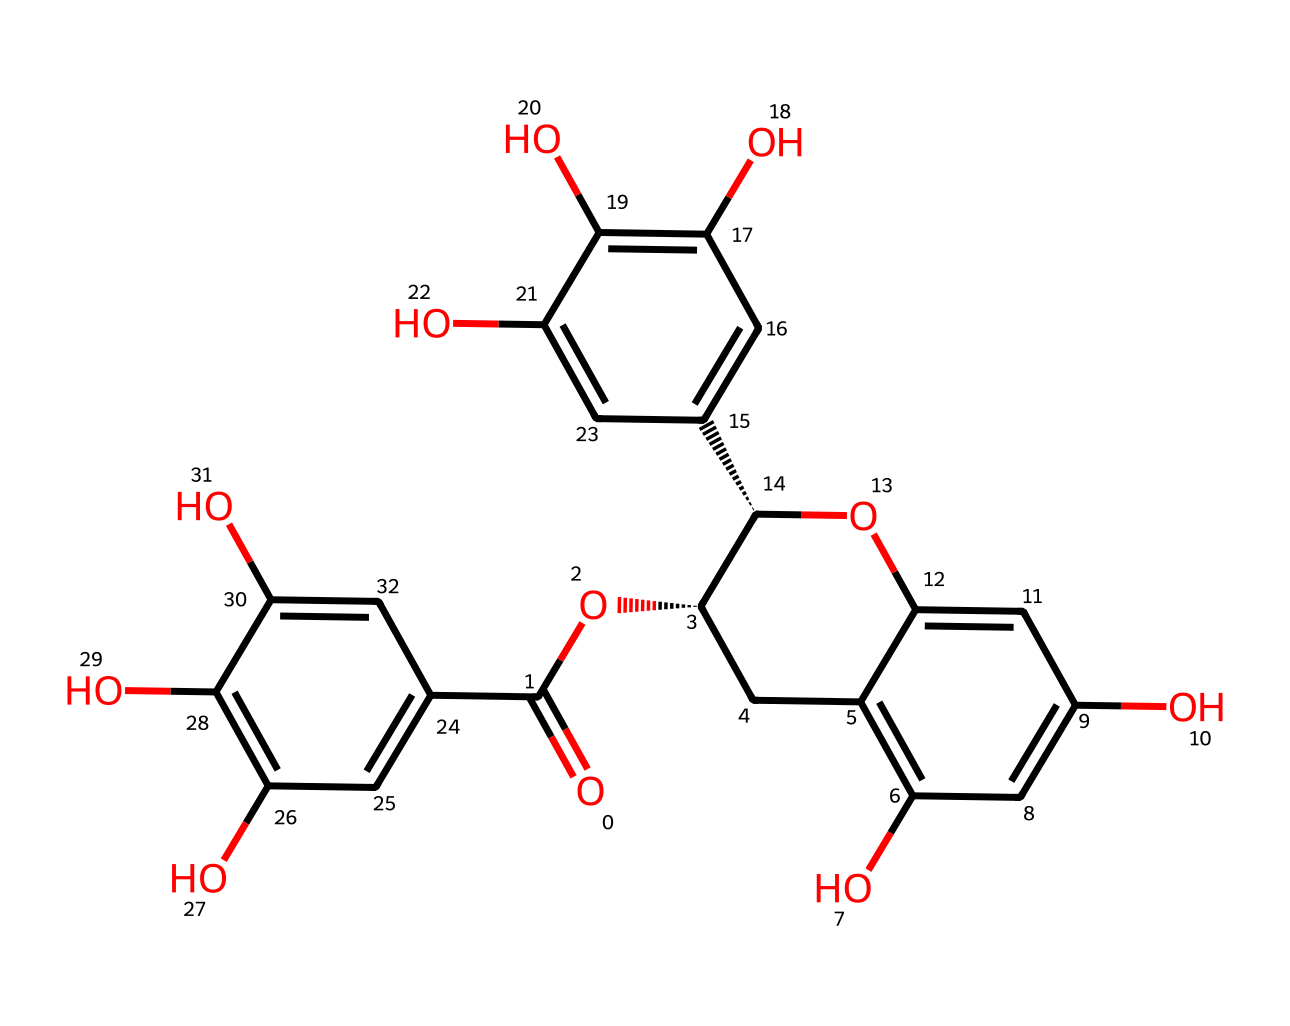What is the molecular formula of this compound? To find the molecular formula, count the number of carbon (C), hydrogen (H), and oxygen (O) atoms in the structure. In this case, there are 22 carbon atoms, 18 hydrogen atoms, and 10 oxygen atoms, which gives a molecular formula of C22H18O10.
Answer: C22H18O10 How many hydroxyl (–OH) groups are present? By analyzing the structure, count the visible hydroxyl groups (which are attached to carbon atoms). In this chemical, there are 5 hydroxyl groups attached to different carbon atoms.
Answer: 5 What type of chemical is this compound classified as? The presence of multiple hydroxyl groups and the complexity of the structure indicate that this compound is a flavonoid, specifically a catechin, a type of antioxidant.
Answer: flavonoid What function does EGCG serve in the body? EGCG acts primarily as an antioxidant, helping to neutralize free radicals and prevent oxidative stress. This function is indicated by the presence of multiple phenolic hydroxyl groups which are responsible for antioxidant activity.
Answer: antioxidant Which structural feature contributes to its antioxidant properties? The multiple hydroxyl groups (–OH) present in the structure are crucial for its antioxidant properties. They can donate hydrogen atoms to free radicals, thus neutralizing them.
Answer: hydroxyl groups 